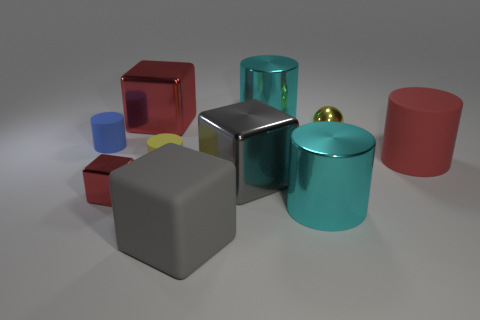Subtract all big rubber blocks. How many blocks are left? 3 Subtract 4 cylinders. How many cylinders are left? 1 Subtract all red blocks. How many blocks are left? 2 Subtract all cubes. How many objects are left? 6 Subtract all gray cylinders. Subtract all green cubes. How many cylinders are left? 5 Subtract all blue cubes. How many cyan cylinders are left? 2 Subtract all shiny cubes. Subtract all rubber blocks. How many objects are left? 6 Add 8 gray blocks. How many gray blocks are left? 10 Add 4 metallic cylinders. How many metallic cylinders exist? 6 Subtract 0 green cylinders. How many objects are left? 10 